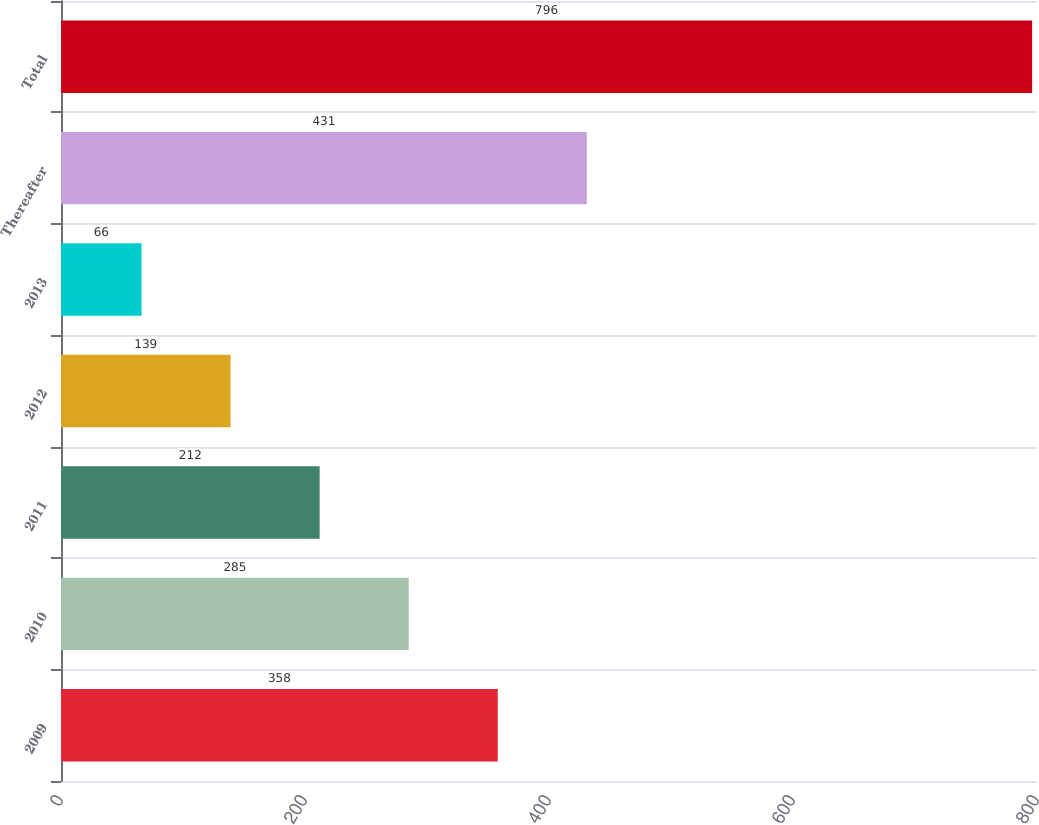Convert chart. <chart><loc_0><loc_0><loc_500><loc_500><bar_chart><fcel>2009<fcel>2010<fcel>2011<fcel>2012<fcel>2013<fcel>Thereafter<fcel>Total<nl><fcel>358<fcel>285<fcel>212<fcel>139<fcel>66<fcel>431<fcel>796<nl></chart> 